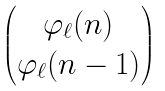<formula> <loc_0><loc_0><loc_500><loc_500>\begin{pmatrix} \varphi _ { \ell } ( n ) \\ \varphi _ { \ell } ( n - 1 ) \end{pmatrix}</formula> 